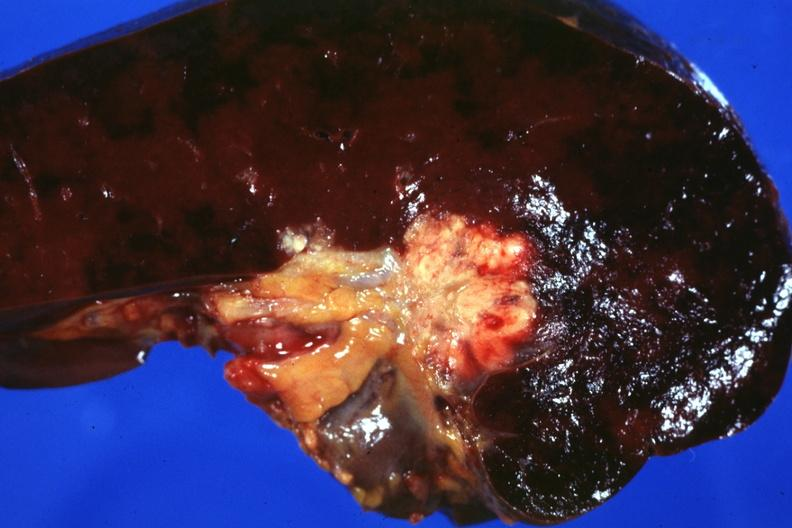do this image show tumor mass in hilum slide and large metastatic nodules in spleen?
Answer the question using a single word or phrase. No 